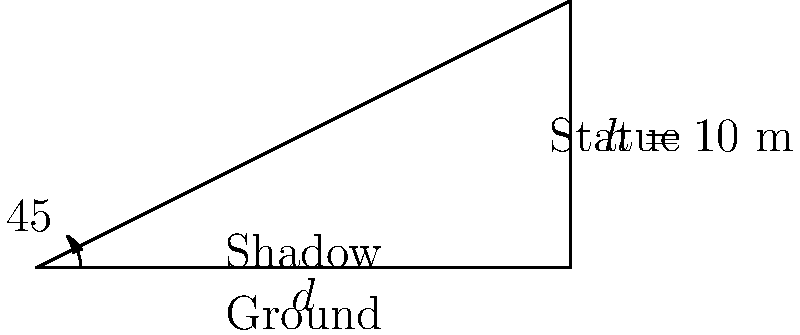A statue of Mother Teresa, a prominent Indian Christian figure, stands 10 meters tall in Kolkata. At a certain time of day, the angle of elevation of the sun is 45°. Calculate the length of the statue's shadow on the ground. To solve this problem, we'll use trigonometry:

1) In a right triangle formed by the statue, its shadow, and the sun's rays, we know:
   - The adjacent side (height of the statue) is 10 meters
   - The angle of elevation of the sun is 45°

2) We need to find the opposite side (length of the shadow)

3) The tangent of an angle in a right triangle is the ratio of the opposite side to the adjacent side:

   $\tan \theta = \frac{\text{opposite}}{\text{adjacent}}$

4) For a 45° angle, $\tan 45° = 1$

5) Let $d$ be the length of the shadow. We can write:

   $\tan 45° = \frac{10}{d} = 1$

6) Solving for $d$:

   $d = 10$

Therefore, the length of the shadow is 10 meters.
Answer: 10 meters 